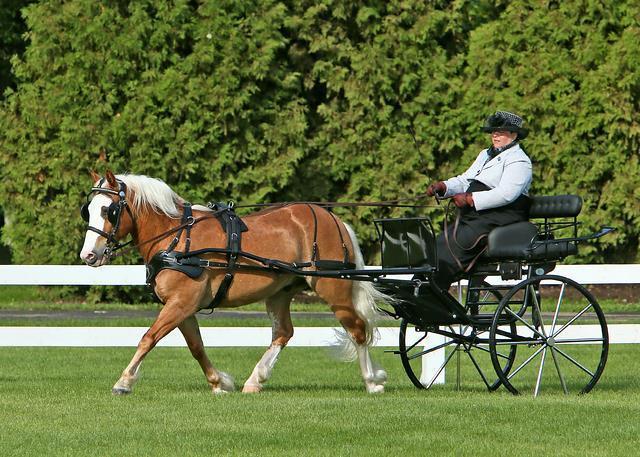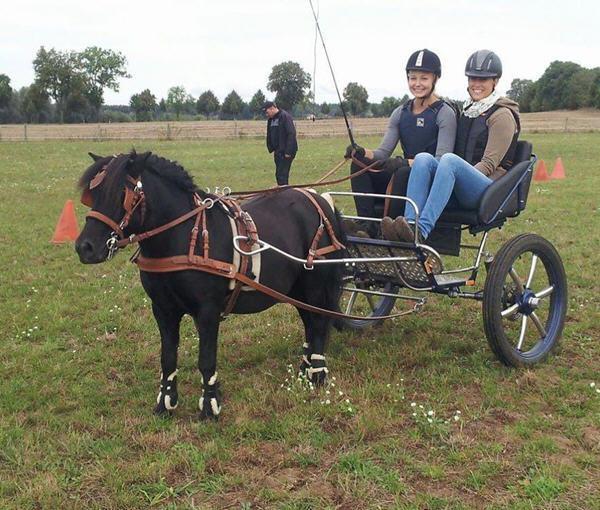The first image is the image on the left, the second image is the image on the right. Evaluate the accuracy of this statement regarding the images: "One image shows a leftward-facing pony with a white mane hitched to a two-wheeled cart carrying one woman in a hat.". Is it true? Answer yes or no. Yes. The first image is the image on the left, the second image is the image on the right. For the images displayed, is the sentence "Horses are transporting people in both images." factually correct? Answer yes or no. Yes. 